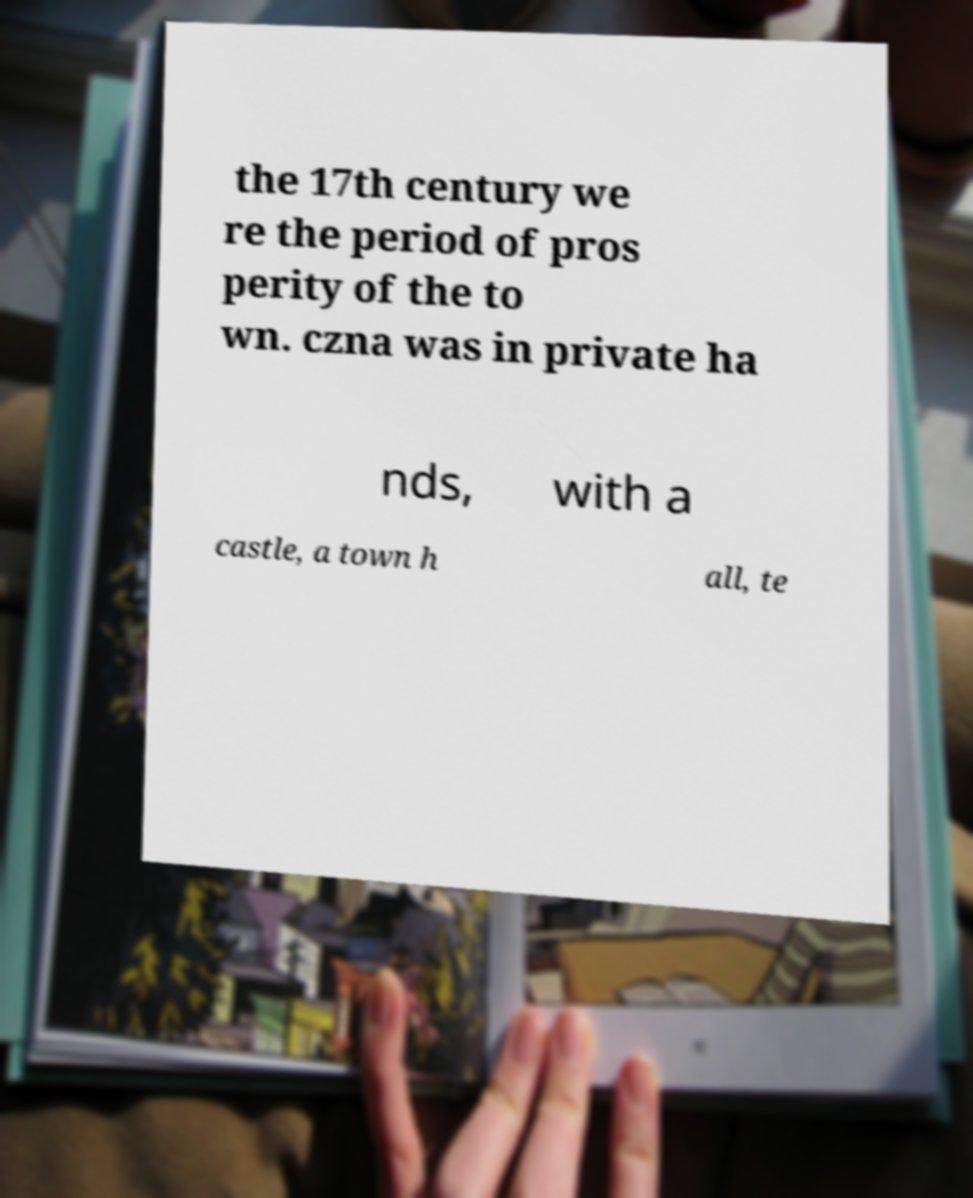Please read and relay the text visible in this image. What does it say? the 17th century we re the period of pros perity of the to wn. czna was in private ha nds, with a castle, a town h all, te 